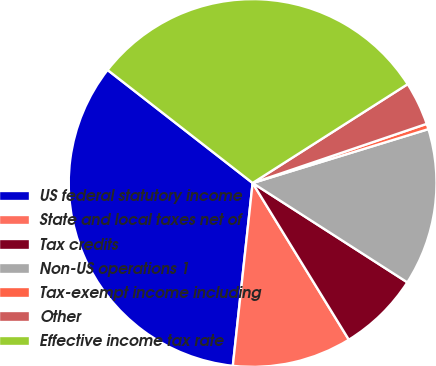Convert chart. <chart><loc_0><loc_0><loc_500><loc_500><pie_chart><fcel>US federal statutory income<fcel>State and local taxes net of<fcel>Tax credits<fcel>Non-US operations 1<fcel>Tax-exempt income including<fcel>Other<fcel>Effective income tax rate<nl><fcel>33.82%<fcel>10.48%<fcel>7.15%<fcel>13.82%<fcel>0.48%<fcel>3.82%<fcel>30.43%<nl></chart> 